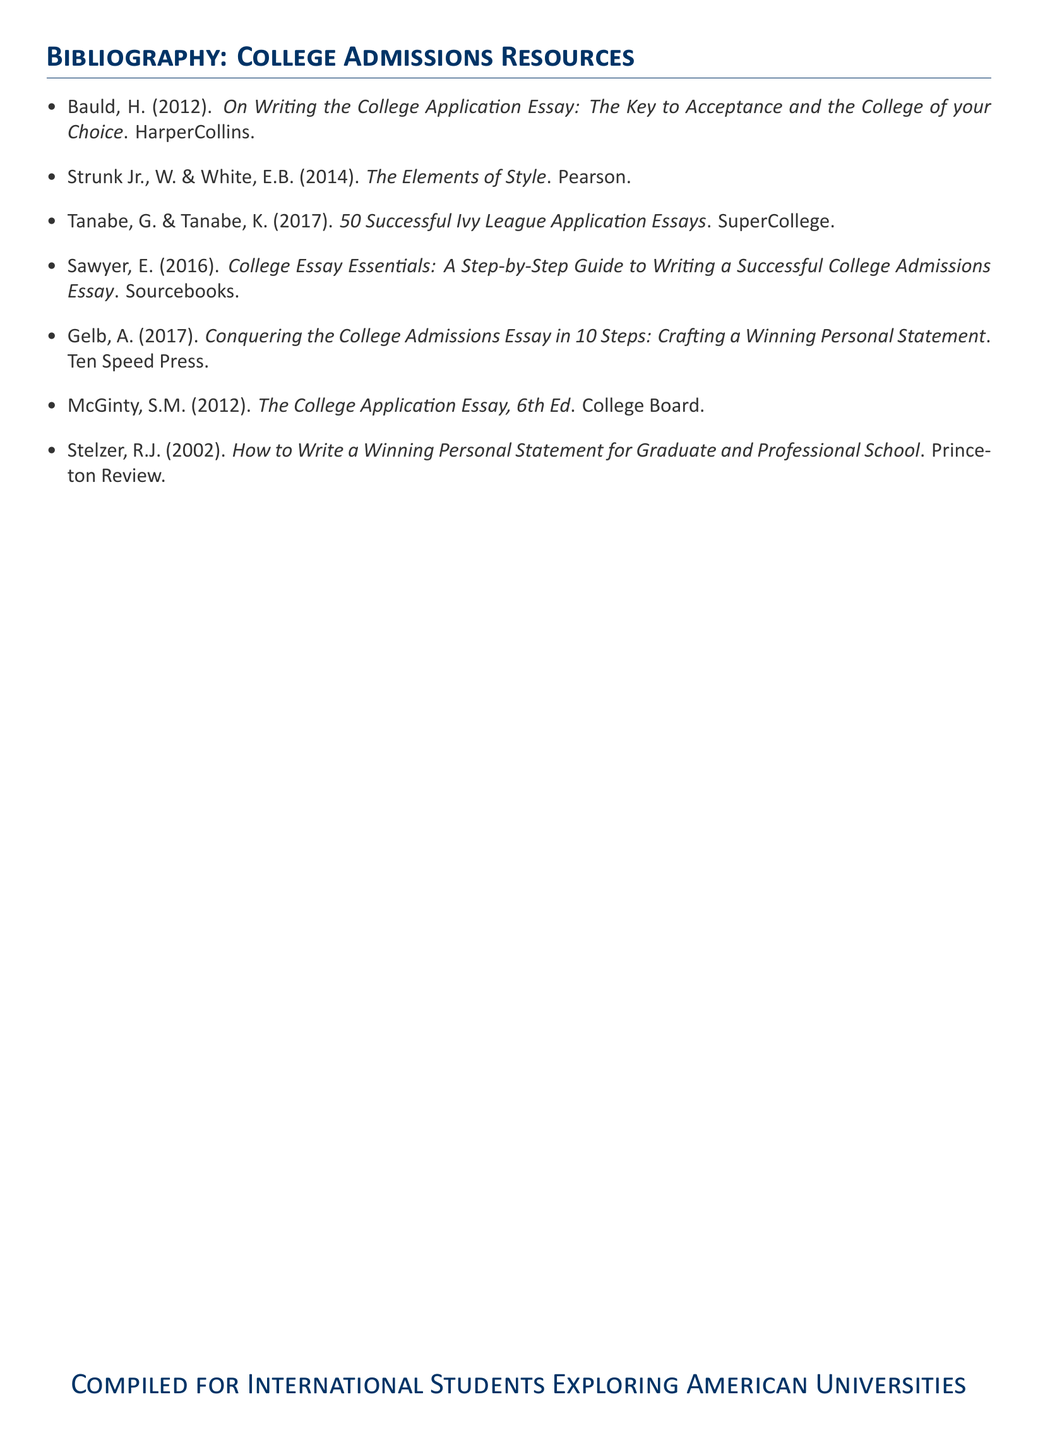What is the title of the first resource listed? The first resource in the bibliography is titled "On Writing the College Application Essay: The Key to Acceptance and the College of your Choice".
Answer: On Writing the College Application Essay: The Key to Acceptance and the College of your Choice Who are the authors of the book "The Elements of Style"? The authors of "The Elements of Style" are William Strunk Jr. and E.B. White.
Answer: William Strunk Jr. and E.B. White What year was "50 Successful Ivy League Application Essays" published? The publication year for "50 Successful Ivy League Application Essays" is 2017.
Answer: 2017 How many steps are suggested in "Conquering the College Admissions Essay in 10 Steps"? The title indicates that there are 10 steps in this resource.
Answer: 10 steps Which publisher released "College Essay Essentials"? The publisher of "College Essay Essentials" is Sourcebooks.
Answer: Sourcebooks What is the main focus of this document? The main focus is on providing resources for international students exploring American universities.
Answer: Resources for international students exploring American universities How many authors collaborated on the book "How to Write a Winning Personal Statement for Graduate and Professional School"? There is one author for this book, R.J. Stelzer.
Answer: One author What is the total number of works cited in the bibliography? The bibliography lists seven works in total.
Answer: Seven works 